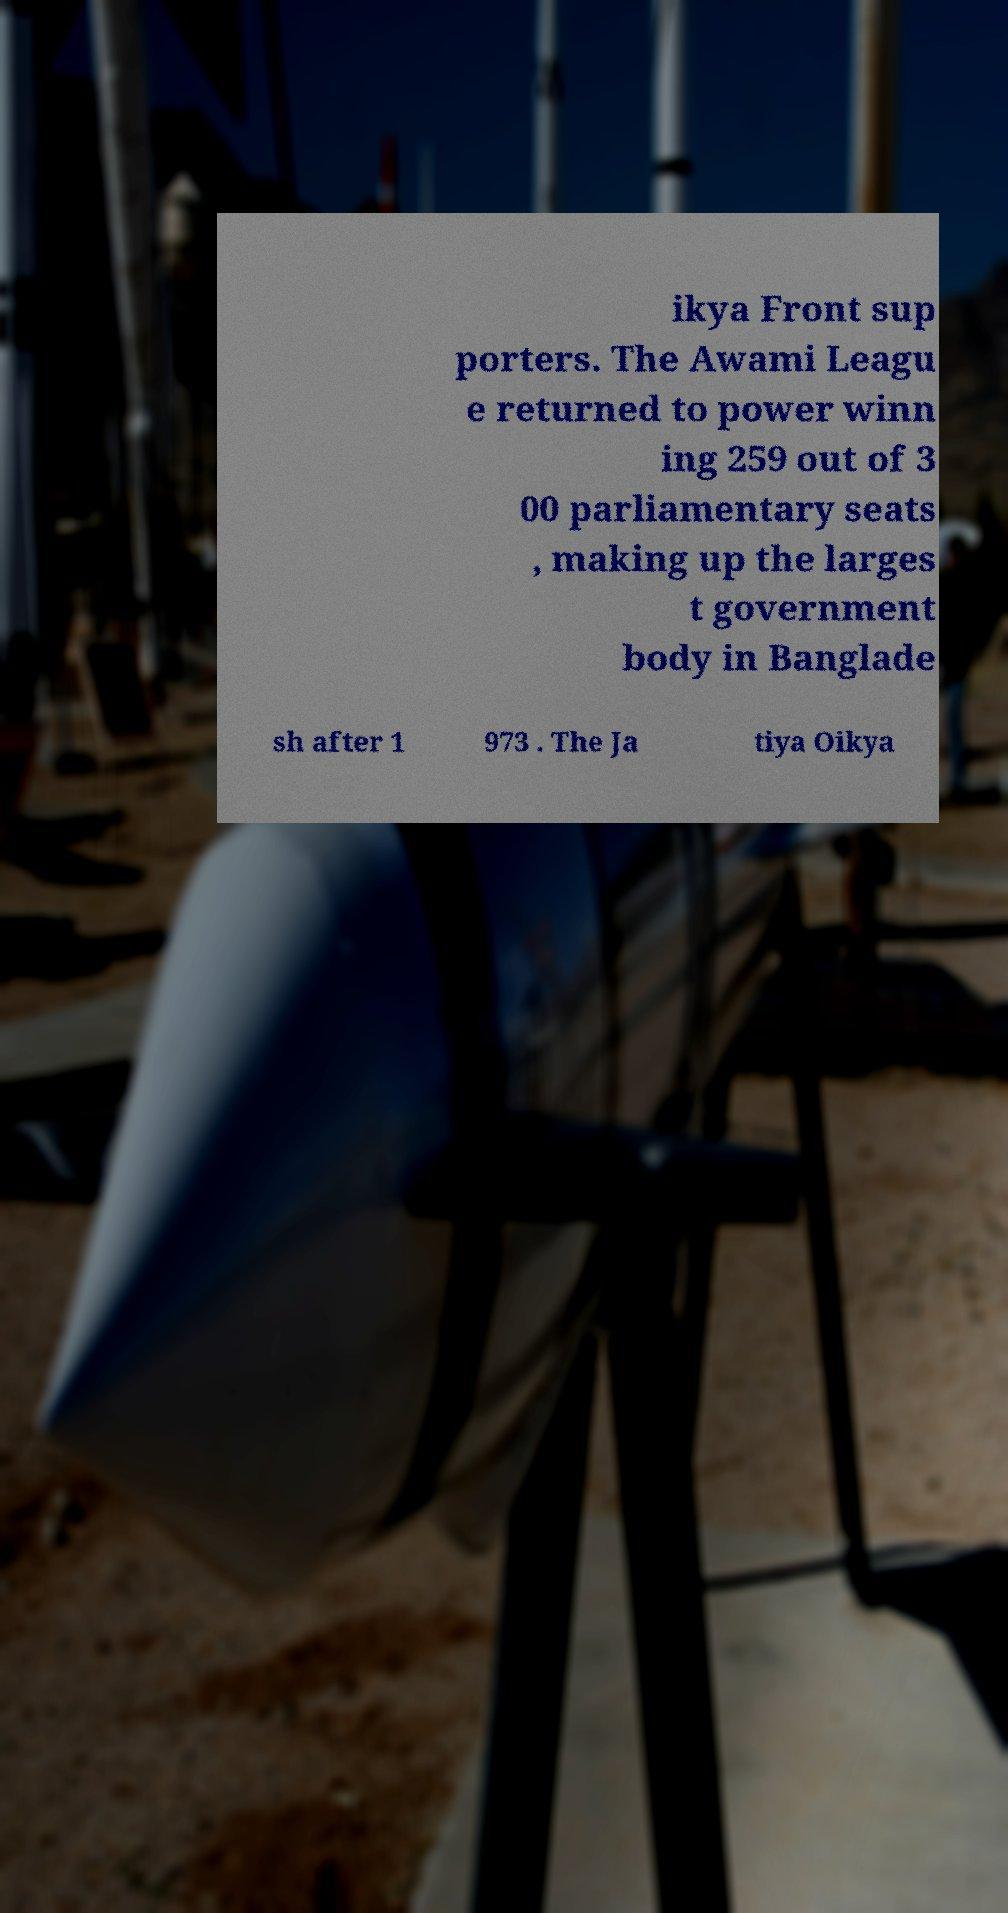Could you extract and type out the text from this image? ikya Front sup porters. The Awami Leagu e returned to power winn ing 259 out of 3 00 parliamentary seats , making up the larges t government body in Banglade sh after 1 973 . The Ja tiya Oikya 